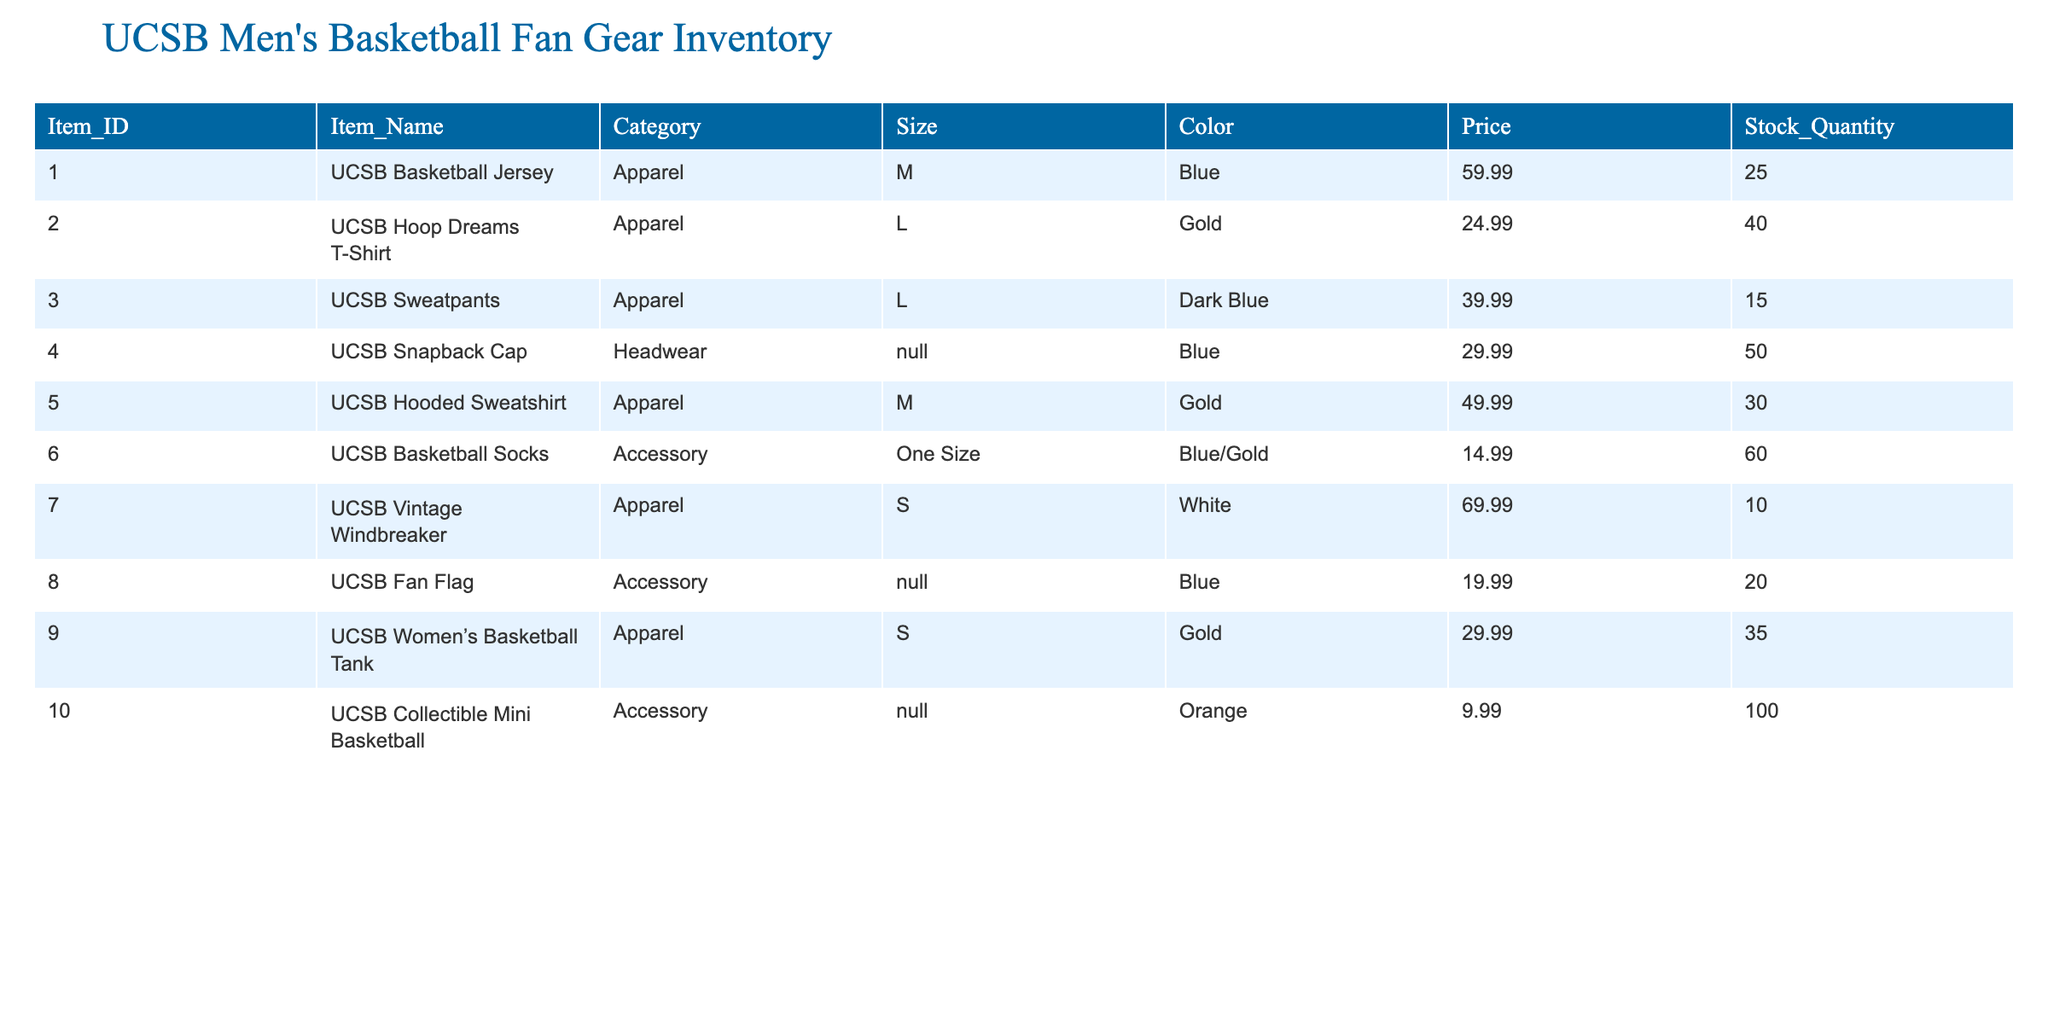What is the price of the UCSB Basketball Jersey? The table shows the price of each item in the "Price" column. For the item "UCSB Basketball Jersey," the corresponding price is listed as 59.99.
Answer: 59.99 How many UCSB Snapback Caps are in stock? By checking the "Stock_Quantity" column for the "UCSB Snapback Cap," we find that the stock quantity is 50.
Answer: 50 What is the total stock quantity of all UCSB men's basketball apparel? To find the total stock of apparel, we will sum the "Stock_Quantity" for all apparel items (Jersey, T-Shirt, Sweatpants, Hooded Sweatshirt, Vintage Windbreaker, Women's Tank). The total is 25 + 40 + 15 + 30 + 10 + 35 = 155.
Answer: 155 Is the UCSB Vintage Windbreaker available in more than 10 units? Looking at the stock quantity for the "UCSB Vintage Windbreaker," which is 10, we can determine that it is not available in more than 10 units.
Answer: No Which item has the highest price among the apparel? Reviewing the "Price" column for apparel items, the UCSB Vintage Windbreaker has a price of 69.99, which is higher than any other apparel item.
Answer: UCSB Vintage Windbreaker How many more UCSB Basketball Socks are available than UCSB Sweatpants? The stock quantity for UCSB Basketball Socks is 60, while for UCSB Sweatpants, it is 15. To find the difference, we subtract 15 from 60: 60 - 15 = 45.
Answer: 45 What is the total price of all UCSB Hooded Sweatshirts in stock? To find the total price of the hooded sweatshirts, we multiply the price per unit (49.99) by the stock quantity (30): 49.99 * 30 = 1499.70.
Answer: 1499.70 Are there more items available in the "Accessory" category than in "Apparel"? There are 3 accessory items in the table and 6 apparel items. Since 3 is less than 6, there are not more items available in the accessory category than in apparel.
Answer: No What is the average price of UCSB men's basketball apparel items? The prices for apparel items are 59.99, 24.99, 39.99, 49.99, 69.99, and 29.99. Adding these gives 59.99 + 24.99 + 39.99 + 49.99 + 69.99 + 29.99 = 294.94. There are 6 items, so dividing gives an average of 294.94 / 6 = 49.16.
Answer: 49.16 